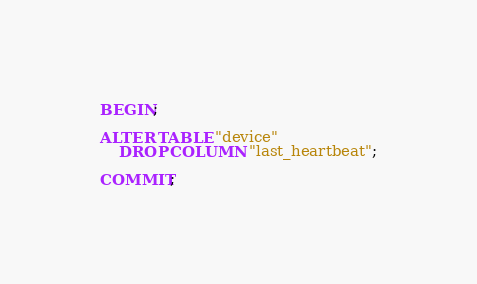<code> <loc_0><loc_0><loc_500><loc_500><_SQL_>BEGIN;

ALTER TABLE "device"
    DROP COLUMN "last_heartbeat";

COMMIT;
</code> 